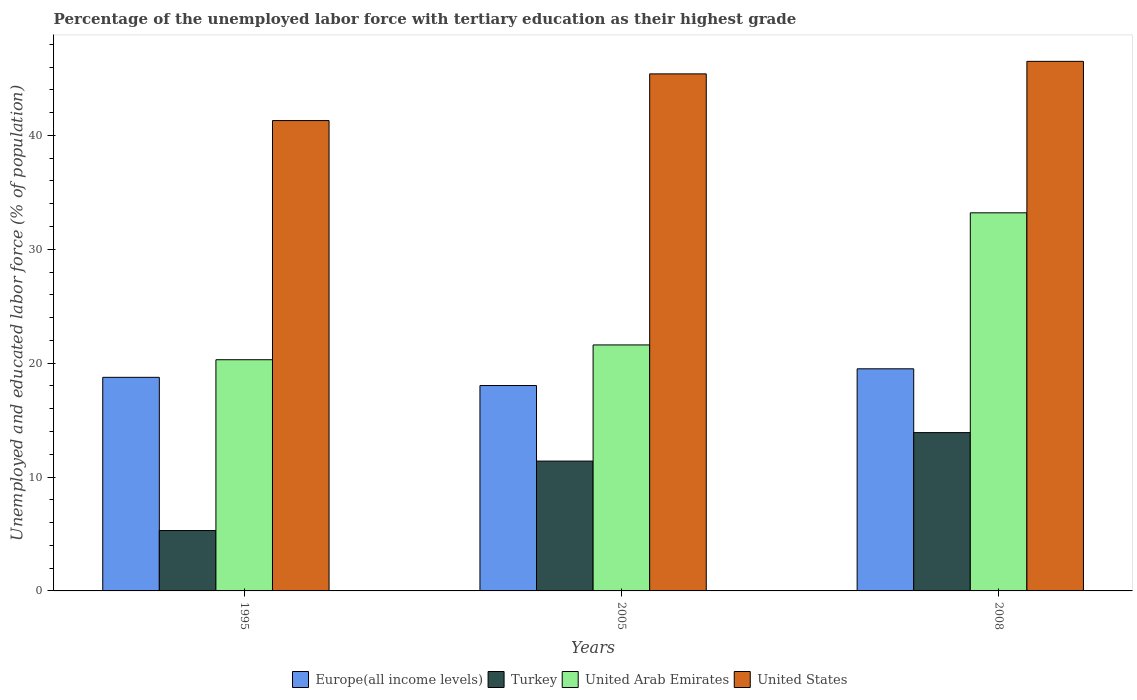How many different coloured bars are there?
Give a very brief answer. 4. What is the label of the 2nd group of bars from the left?
Keep it short and to the point. 2005. What is the percentage of the unemployed labor force with tertiary education in United States in 2008?
Your response must be concise. 46.5. Across all years, what is the maximum percentage of the unemployed labor force with tertiary education in Turkey?
Your response must be concise. 13.9. Across all years, what is the minimum percentage of the unemployed labor force with tertiary education in Turkey?
Provide a short and direct response. 5.3. What is the total percentage of the unemployed labor force with tertiary education in Turkey in the graph?
Keep it short and to the point. 30.6. What is the difference between the percentage of the unemployed labor force with tertiary education in Turkey in 1995 and that in 2008?
Offer a very short reply. -8.6. What is the difference between the percentage of the unemployed labor force with tertiary education in United Arab Emirates in 2008 and the percentage of the unemployed labor force with tertiary education in Europe(all income levels) in 2005?
Provide a short and direct response. 15.17. What is the average percentage of the unemployed labor force with tertiary education in Turkey per year?
Your response must be concise. 10.2. In the year 1995, what is the difference between the percentage of the unemployed labor force with tertiary education in United States and percentage of the unemployed labor force with tertiary education in United Arab Emirates?
Provide a succinct answer. 21. In how many years, is the percentage of the unemployed labor force with tertiary education in United Arab Emirates greater than 22 %?
Keep it short and to the point. 1. What is the ratio of the percentage of the unemployed labor force with tertiary education in Europe(all income levels) in 2005 to that in 2008?
Your answer should be compact. 0.92. What is the difference between the highest and the lowest percentage of the unemployed labor force with tertiary education in Europe(all income levels)?
Ensure brevity in your answer.  1.47. In how many years, is the percentage of the unemployed labor force with tertiary education in Europe(all income levels) greater than the average percentage of the unemployed labor force with tertiary education in Europe(all income levels) taken over all years?
Offer a very short reply. 1. Is the sum of the percentage of the unemployed labor force with tertiary education in Europe(all income levels) in 1995 and 2005 greater than the maximum percentage of the unemployed labor force with tertiary education in United Arab Emirates across all years?
Your answer should be very brief. Yes. What does the 2nd bar from the left in 1995 represents?
Give a very brief answer. Turkey. Is it the case that in every year, the sum of the percentage of the unemployed labor force with tertiary education in United Arab Emirates and percentage of the unemployed labor force with tertiary education in Turkey is greater than the percentage of the unemployed labor force with tertiary education in Europe(all income levels)?
Keep it short and to the point. Yes. How many bars are there?
Make the answer very short. 12. Are all the bars in the graph horizontal?
Provide a short and direct response. No. What is the difference between two consecutive major ticks on the Y-axis?
Your response must be concise. 10. Does the graph contain any zero values?
Give a very brief answer. No. How are the legend labels stacked?
Make the answer very short. Horizontal. What is the title of the graph?
Ensure brevity in your answer.  Percentage of the unemployed labor force with tertiary education as their highest grade. Does "United Arab Emirates" appear as one of the legend labels in the graph?
Offer a very short reply. Yes. What is the label or title of the X-axis?
Offer a terse response. Years. What is the label or title of the Y-axis?
Your answer should be compact. Unemployed and educated labor force (% of population). What is the Unemployed and educated labor force (% of population) of Europe(all income levels) in 1995?
Make the answer very short. 18.75. What is the Unemployed and educated labor force (% of population) in Turkey in 1995?
Give a very brief answer. 5.3. What is the Unemployed and educated labor force (% of population) of United Arab Emirates in 1995?
Ensure brevity in your answer.  20.3. What is the Unemployed and educated labor force (% of population) of United States in 1995?
Provide a succinct answer. 41.3. What is the Unemployed and educated labor force (% of population) of Europe(all income levels) in 2005?
Offer a very short reply. 18.03. What is the Unemployed and educated labor force (% of population) of Turkey in 2005?
Ensure brevity in your answer.  11.4. What is the Unemployed and educated labor force (% of population) of United Arab Emirates in 2005?
Offer a very short reply. 21.6. What is the Unemployed and educated labor force (% of population) of United States in 2005?
Your answer should be very brief. 45.4. What is the Unemployed and educated labor force (% of population) of Europe(all income levels) in 2008?
Provide a short and direct response. 19.5. What is the Unemployed and educated labor force (% of population) of Turkey in 2008?
Offer a very short reply. 13.9. What is the Unemployed and educated labor force (% of population) in United Arab Emirates in 2008?
Make the answer very short. 33.2. What is the Unemployed and educated labor force (% of population) of United States in 2008?
Ensure brevity in your answer.  46.5. Across all years, what is the maximum Unemployed and educated labor force (% of population) in Europe(all income levels)?
Make the answer very short. 19.5. Across all years, what is the maximum Unemployed and educated labor force (% of population) of Turkey?
Offer a very short reply. 13.9. Across all years, what is the maximum Unemployed and educated labor force (% of population) in United Arab Emirates?
Make the answer very short. 33.2. Across all years, what is the maximum Unemployed and educated labor force (% of population) in United States?
Offer a terse response. 46.5. Across all years, what is the minimum Unemployed and educated labor force (% of population) in Europe(all income levels)?
Your answer should be compact. 18.03. Across all years, what is the minimum Unemployed and educated labor force (% of population) of Turkey?
Your answer should be very brief. 5.3. Across all years, what is the minimum Unemployed and educated labor force (% of population) in United Arab Emirates?
Ensure brevity in your answer.  20.3. Across all years, what is the minimum Unemployed and educated labor force (% of population) of United States?
Provide a short and direct response. 41.3. What is the total Unemployed and educated labor force (% of population) of Europe(all income levels) in the graph?
Provide a short and direct response. 56.29. What is the total Unemployed and educated labor force (% of population) of Turkey in the graph?
Make the answer very short. 30.6. What is the total Unemployed and educated labor force (% of population) in United Arab Emirates in the graph?
Make the answer very short. 75.1. What is the total Unemployed and educated labor force (% of population) of United States in the graph?
Your answer should be very brief. 133.2. What is the difference between the Unemployed and educated labor force (% of population) in Europe(all income levels) in 1995 and that in 2005?
Give a very brief answer. 0.72. What is the difference between the Unemployed and educated labor force (% of population) of United States in 1995 and that in 2005?
Ensure brevity in your answer.  -4.1. What is the difference between the Unemployed and educated labor force (% of population) of Europe(all income levels) in 1995 and that in 2008?
Offer a terse response. -0.75. What is the difference between the Unemployed and educated labor force (% of population) in United States in 1995 and that in 2008?
Your answer should be compact. -5.2. What is the difference between the Unemployed and educated labor force (% of population) of Europe(all income levels) in 2005 and that in 2008?
Offer a terse response. -1.47. What is the difference between the Unemployed and educated labor force (% of population) of United Arab Emirates in 2005 and that in 2008?
Offer a very short reply. -11.6. What is the difference between the Unemployed and educated labor force (% of population) in Europe(all income levels) in 1995 and the Unemployed and educated labor force (% of population) in Turkey in 2005?
Offer a very short reply. 7.35. What is the difference between the Unemployed and educated labor force (% of population) in Europe(all income levels) in 1995 and the Unemployed and educated labor force (% of population) in United Arab Emirates in 2005?
Offer a terse response. -2.85. What is the difference between the Unemployed and educated labor force (% of population) of Europe(all income levels) in 1995 and the Unemployed and educated labor force (% of population) of United States in 2005?
Give a very brief answer. -26.65. What is the difference between the Unemployed and educated labor force (% of population) of Turkey in 1995 and the Unemployed and educated labor force (% of population) of United Arab Emirates in 2005?
Ensure brevity in your answer.  -16.3. What is the difference between the Unemployed and educated labor force (% of population) of Turkey in 1995 and the Unemployed and educated labor force (% of population) of United States in 2005?
Offer a very short reply. -40.1. What is the difference between the Unemployed and educated labor force (% of population) of United Arab Emirates in 1995 and the Unemployed and educated labor force (% of population) of United States in 2005?
Your response must be concise. -25.1. What is the difference between the Unemployed and educated labor force (% of population) in Europe(all income levels) in 1995 and the Unemployed and educated labor force (% of population) in Turkey in 2008?
Offer a terse response. 4.85. What is the difference between the Unemployed and educated labor force (% of population) of Europe(all income levels) in 1995 and the Unemployed and educated labor force (% of population) of United Arab Emirates in 2008?
Provide a short and direct response. -14.45. What is the difference between the Unemployed and educated labor force (% of population) of Europe(all income levels) in 1995 and the Unemployed and educated labor force (% of population) of United States in 2008?
Ensure brevity in your answer.  -27.75. What is the difference between the Unemployed and educated labor force (% of population) of Turkey in 1995 and the Unemployed and educated labor force (% of population) of United Arab Emirates in 2008?
Offer a very short reply. -27.9. What is the difference between the Unemployed and educated labor force (% of population) in Turkey in 1995 and the Unemployed and educated labor force (% of population) in United States in 2008?
Keep it short and to the point. -41.2. What is the difference between the Unemployed and educated labor force (% of population) of United Arab Emirates in 1995 and the Unemployed and educated labor force (% of population) of United States in 2008?
Provide a succinct answer. -26.2. What is the difference between the Unemployed and educated labor force (% of population) of Europe(all income levels) in 2005 and the Unemployed and educated labor force (% of population) of Turkey in 2008?
Make the answer very short. 4.13. What is the difference between the Unemployed and educated labor force (% of population) of Europe(all income levels) in 2005 and the Unemployed and educated labor force (% of population) of United Arab Emirates in 2008?
Make the answer very short. -15.17. What is the difference between the Unemployed and educated labor force (% of population) of Europe(all income levels) in 2005 and the Unemployed and educated labor force (% of population) of United States in 2008?
Provide a short and direct response. -28.47. What is the difference between the Unemployed and educated labor force (% of population) of Turkey in 2005 and the Unemployed and educated labor force (% of population) of United Arab Emirates in 2008?
Provide a short and direct response. -21.8. What is the difference between the Unemployed and educated labor force (% of population) of Turkey in 2005 and the Unemployed and educated labor force (% of population) of United States in 2008?
Offer a very short reply. -35.1. What is the difference between the Unemployed and educated labor force (% of population) in United Arab Emirates in 2005 and the Unemployed and educated labor force (% of population) in United States in 2008?
Your answer should be very brief. -24.9. What is the average Unemployed and educated labor force (% of population) in Europe(all income levels) per year?
Ensure brevity in your answer.  18.76. What is the average Unemployed and educated labor force (% of population) of United Arab Emirates per year?
Give a very brief answer. 25.03. What is the average Unemployed and educated labor force (% of population) of United States per year?
Keep it short and to the point. 44.4. In the year 1995, what is the difference between the Unemployed and educated labor force (% of population) in Europe(all income levels) and Unemployed and educated labor force (% of population) in Turkey?
Make the answer very short. 13.45. In the year 1995, what is the difference between the Unemployed and educated labor force (% of population) in Europe(all income levels) and Unemployed and educated labor force (% of population) in United Arab Emirates?
Offer a terse response. -1.55. In the year 1995, what is the difference between the Unemployed and educated labor force (% of population) of Europe(all income levels) and Unemployed and educated labor force (% of population) of United States?
Keep it short and to the point. -22.55. In the year 1995, what is the difference between the Unemployed and educated labor force (% of population) of Turkey and Unemployed and educated labor force (% of population) of United States?
Give a very brief answer. -36. In the year 2005, what is the difference between the Unemployed and educated labor force (% of population) of Europe(all income levels) and Unemployed and educated labor force (% of population) of Turkey?
Make the answer very short. 6.63. In the year 2005, what is the difference between the Unemployed and educated labor force (% of population) of Europe(all income levels) and Unemployed and educated labor force (% of population) of United Arab Emirates?
Your response must be concise. -3.57. In the year 2005, what is the difference between the Unemployed and educated labor force (% of population) of Europe(all income levels) and Unemployed and educated labor force (% of population) of United States?
Keep it short and to the point. -27.37. In the year 2005, what is the difference between the Unemployed and educated labor force (% of population) in Turkey and Unemployed and educated labor force (% of population) in United Arab Emirates?
Your answer should be compact. -10.2. In the year 2005, what is the difference between the Unemployed and educated labor force (% of population) of Turkey and Unemployed and educated labor force (% of population) of United States?
Ensure brevity in your answer.  -34. In the year 2005, what is the difference between the Unemployed and educated labor force (% of population) in United Arab Emirates and Unemployed and educated labor force (% of population) in United States?
Your answer should be very brief. -23.8. In the year 2008, what is the difference between the Unemployed and educated labor force (% of population) of Europe(all income levels) and Unemployed and educated labor force (% of population) of Turkey?
Offer a very short reply. 5.6. In the year 2008, what is the difference between the Unemployed and educated labor force (% of population) of Europe(all income levels) and Unemployed and educated labor force (% of population) of United Arab Emirates?
Offer a very short reply. -13.7. In the year 2008, what is the difference between the Unemployed and educated labor force (% of population) in Europe(all income levels) and Unemployed and educated labor force (% of population) in United States?
Offer a very short reply. -27. In the year 2008, what is the difference between the Unemployed and educated labor force (% of population) of Turkey and Unemployed and educated labor force (% of population) of United Arab Emirates?
Offer a very short reply. -19.3. In the year 2008, what is the difference between the Unemployed and educated labor force (% of population) of Turkey and Unemployed and educated labor force (% of population) of United States?
Provide a succinct answer. -32.6. In the year 2008, what is the difference between the Unemployed and educated labor force (% of population) of United Arab Emirates and Unemployed and educated labor force (% of population) of United States?
Make the answer very short. -13.3. What is the ratio of the Unemployed and educated labor force (% of population) of Europe(all income levels) in 1995 to that in 2005?
Make the answer very short. 1.04. What is the ratio of the Unemployed and educated labor force (% of population) in Turkey in 1995 to that in 2005?
Your answer should be compact. 0.46. What is the ratio of the Unemployed and educated labor force (% of population) of United Arab Emirates in 1995 to that in 2005?
Your answer should be compact. 0.94. What is the ratio of the Unemployed and educated labor force (% of population) in United States in 1995 to that in 2005?
Your answer should be compact. 0.91. What is the ratio of the Unemployed and educated labor force (% of population) of Europe(all income levels) in 1995 to that in 2008?
Ensure brevity in your answer.  0.96. What is the ratio of the Unemployed and educated labor force (% of population) of Turkey in 1995 to that in 2008?
Your answer should be very brief. 0.38. What is the ratio of the Unemployed and educated labor force (% of population) of United Arab Emirates in 1995 to that in 2008?
Offer a very short reply. 0.61. What is the ratio of the Unemployed and educated labor force (% of population) in United States in 1995 to that in 2008?
Offer a very short reply. 0.89. What is the ratio of the Unemployed and educated labor force (% of population) in Europe(all income levels) in 2005 to that in 2008?
Your response must be concise. 0.92. What is the ratio of the Unemployed and educated labor force (% of population) in Turkey in 2005 to that in 2008?
Your response must be concise. 0.82. What is the ratio of the Unemployed and educated labor force (% of population) of United Arab Emirates in 2005 to that in 2008?
Offer a terse response. 0.65. What is the ratio of the Unemployed and educated labor force (% of population) of United States in 2005 to that in 2008?
Give a very brief answer. 0.98. What is the difference between the highest and the second highest Unemployed and educated labor force (% of population) of Europe(all income levels)?
Ensure brevity in your answer.  0.75. What is the difference between the highest and the second highest Unemployed and educated labor force (% of population) of United Arab Emirates?
Your answer should be compact. 11.6. What is the difference between the highest and the lowest Unemployed and educated labor force (% of population) of Europe(all income levels)?
Make the answer very short. 1.47. What is the difference between the highest and the lowest Unemployed and educated labor force (% of population) in Turkey?
Offer a very short reply. 8.6. What is the difference between the highest and the lowest Unemployed and educated labor force (% of population) in United Arab Emirates?
Give a very brief answer. 12.9. 